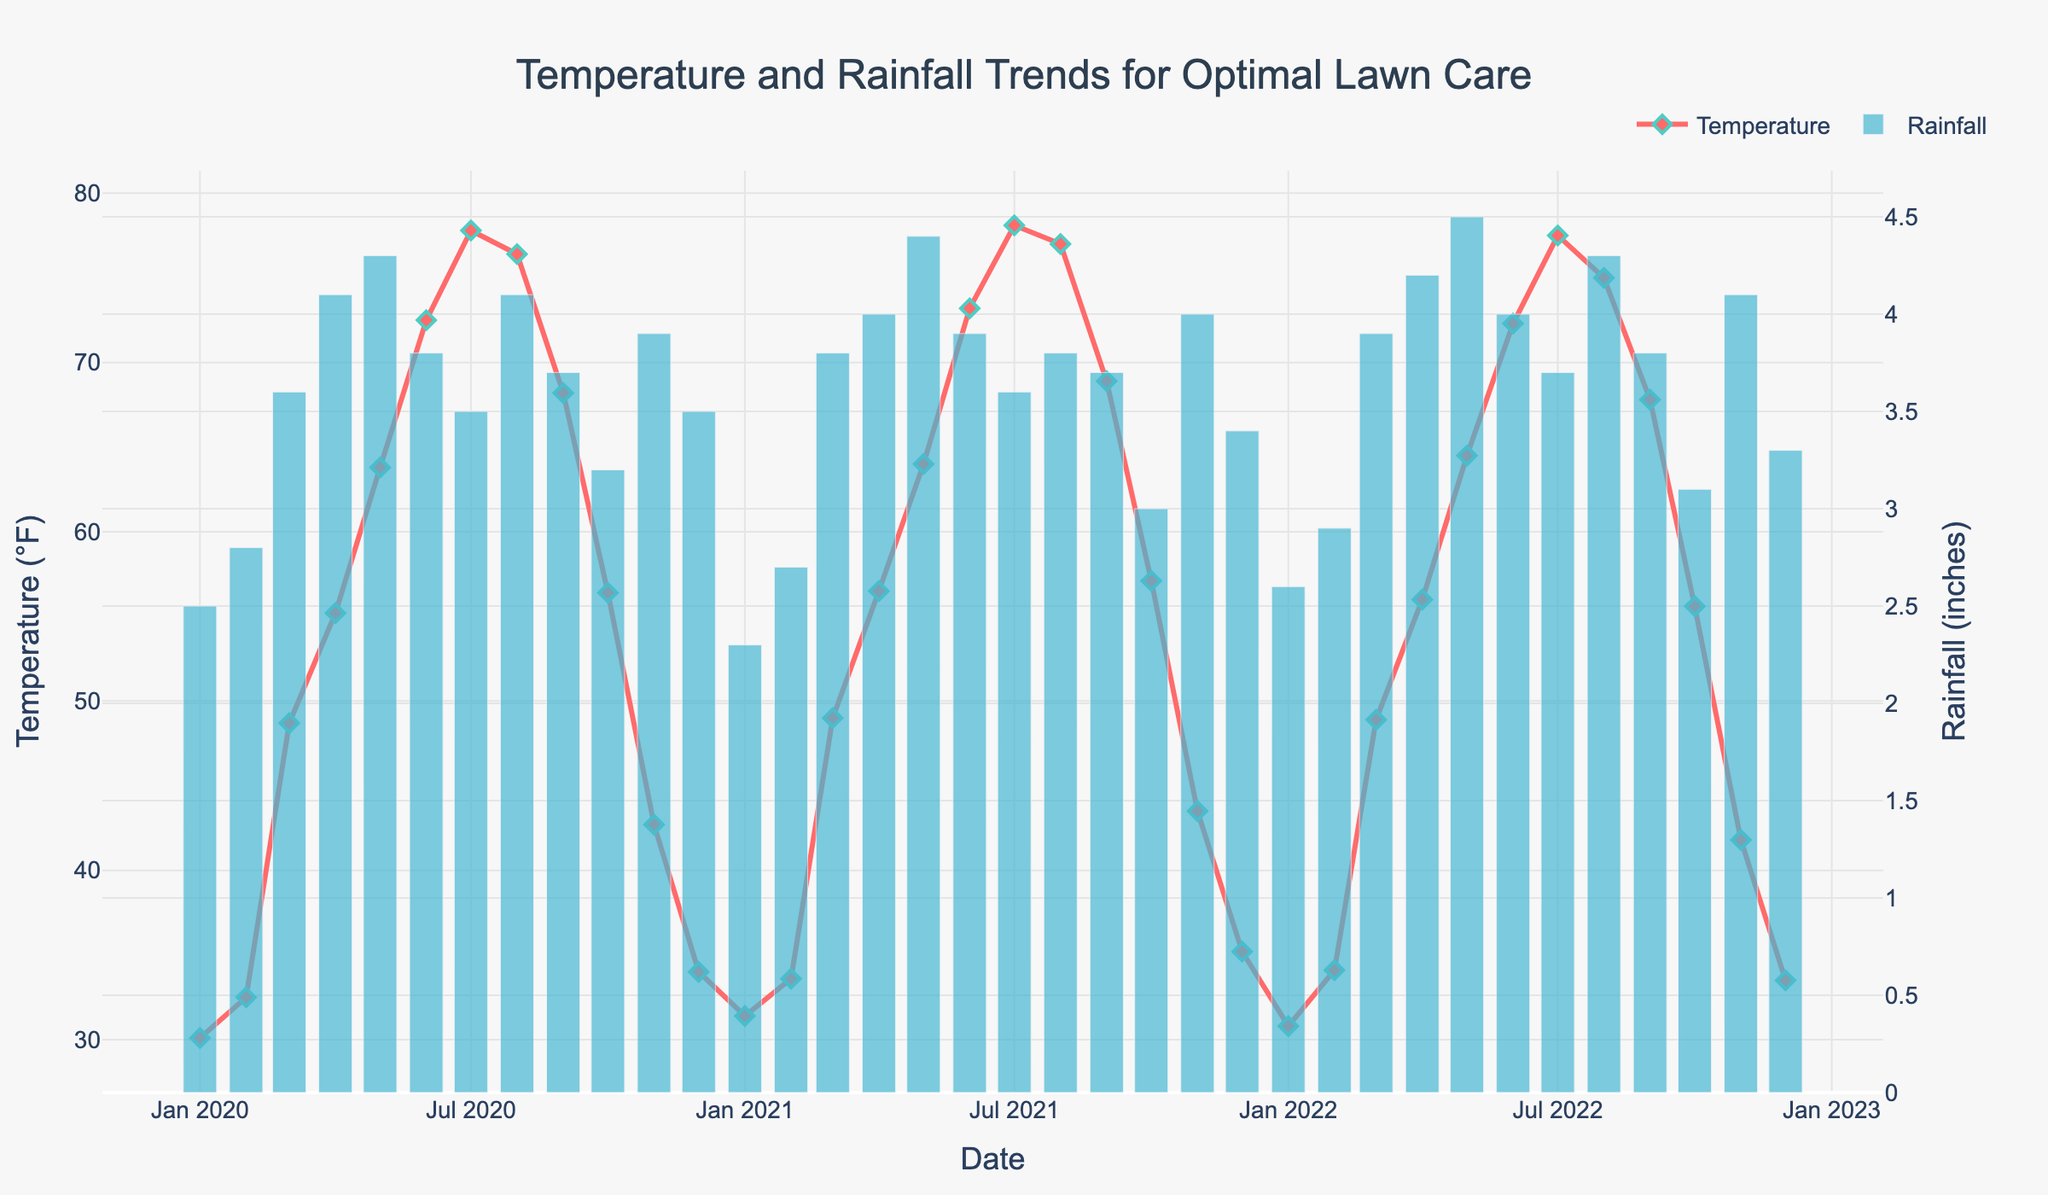What's the title of the plot? The title of the plot is located at the top center of the figure and reads "Temperature and Rainfall Trends for Optimal Lawn Care".
Answer: Temperature and Rainfall Trends for Optimal Lawn Care What are the colors used for the temperature and rainfall lines? The temperature line is displayed in red with diamond markers in green, and the rainfall bars are colored blue.
Answer: Red and blue What month has the highest average temperature and what is it? Find the highest point on the temperature line and refer to the corresponding month on the x-axis. The highest average temperature occurs in July with approximately 78.1°F in July 2021.
Answer: July 2021, 78.1°F Which month had the maximum rainfall over the three years and how much was it? Identify the highest bar in the rainfall series on the plot. The tallest bar appears in May 2022 with rainfall measuring around 4.5 inches.
Answer: May 2022, 4.5 inches Which year had the highest overall average temperature in December? Locate the average temperatures for December across the three years and compare them. December of 2021 had the highest average temperature of 35.2°F.
Answer: 2021 How does the average temperature in February 2022 compare to February 2020? Compare the height of the temperature points in February 2022 and February 2020. February 2022 had a higher average temperature (34.1°F) compared to February 2020 (32.5°F).
Answer: February 2022 had a higher average temperature Between July 2020 and July 2021, which month had higher rainfall? Compare the heights of the rainfall bars for July 2020 and July 2021. July 2021 had higher rainfall (3.6 inches) compared to July 2020 (3.5 inches).
Answer: July 2021 What is the trend in average temperature from January to December for each year? Trace the temperature line from January to December for each year; the average temperature increases from January, peaks during summer months, and then decreases by December.
Answer: Temperature increases then decreases What is the average temperature for the entire period shown on the plot? Sum all the temperature values and divide by the number of data points (36 in total). The average temperature is approximately (30.1 + 32.5 + 48.7 + 55.2 + 63.8 + 72.5 + 77.8 + 76.4 + 68.2 + 56.4 + 42.7 + 34.0 + 31.4 + 33.6 + 49.0 + 56.5 + 64.0 + 73.2 + 78.1 + 77.0 + 68.9 + 57.1 + 43.5 + 35.2 + 30.8 + 34.1 + 48.9 + 56.0 + 64.5 + 72.3 + 77.5 + 75.0 + 67.8 + 55.6 + 41.8 + 33.5) / 36 = 54.8°F.
Answer: 54.8°F 